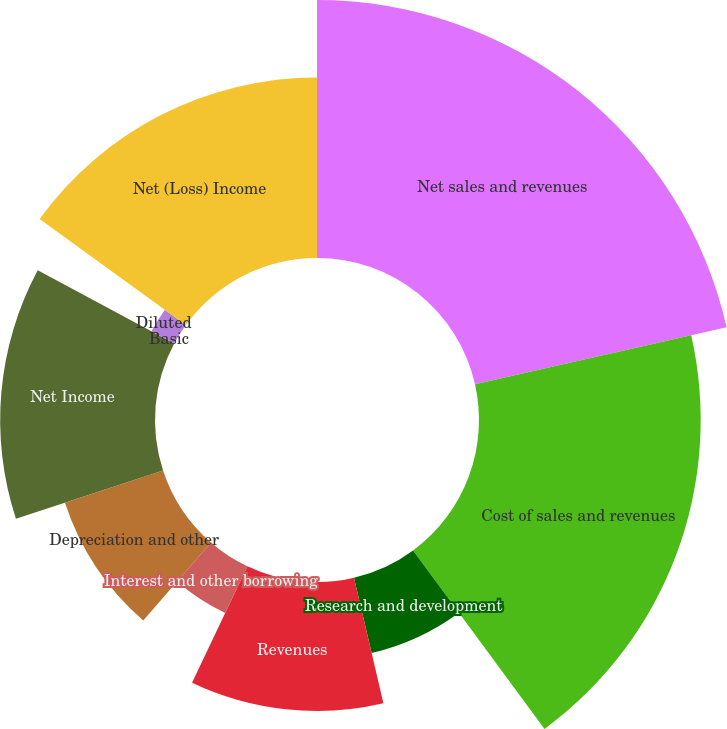Convert chart to OTSL. <chart><loc_0><loc_0><loc_500><loc_500><pie_chart><fcel>Net sales and revenues<fcel>Cost of sales and revenues<fcel>Research and development<fcel>Revenues<fcel>Interest and other borrowing<fcel>Depreciation and other<fcel>Net Income<fcel>Basic<fcel>Diluted<fcel>Net (Loss) Income<nl><fcel>21.46%<fcel>18.44%<fcel>6.44%<fcel>10.73%<fcel>4.3%<fcel>8.59%<fcel>12.88%<fcel>0.0%<fcel>2.15%<fcel>15.02%<nl></chart> 